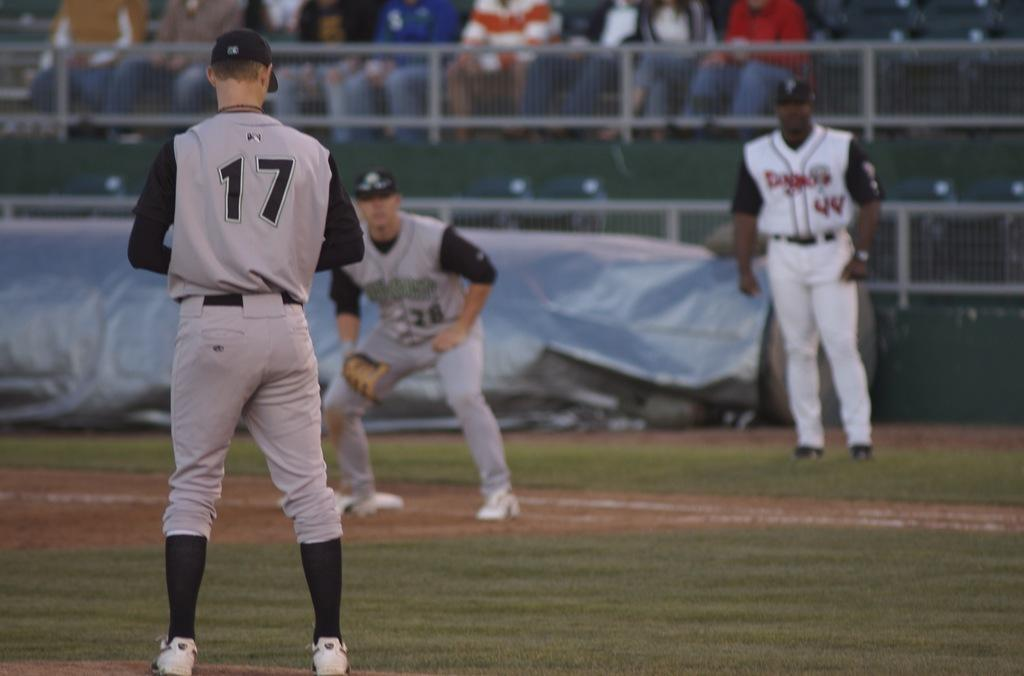<image>
Share a concise interpretation of the image provided. number 17 is preparing to throw the ball toward another player 